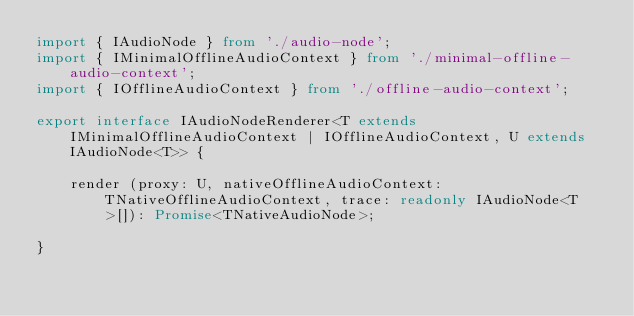Convert code to text. <code><loc_0><loc_0><loc_500><loc_500><_TypeScript_>import { IAudioNode } from './audio-node';
import { IMinimalOfflineAudioContext } from './minimal-offline-audio-context';
import { IOfflineAudioContext } from './offline-audio-context';

export interface IAudioNodeRenderer<T extends IMinimalOfflineAudioContext | IOfflineAudioContext, U extends IAudioNode<T>> {

    render (proxy: U, nativeOfflineAudioContext: TNativeOfflineAudioContext, trace: readonly IAudioNode<T>[]): Promise<TNativeAudioNode>;

}
</code> 